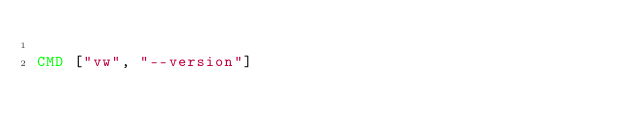<code> <loc_0><loc_0><loc_500><loc_500><_Dockerfile_>
CMD ["vw", "--version"]
</code> 